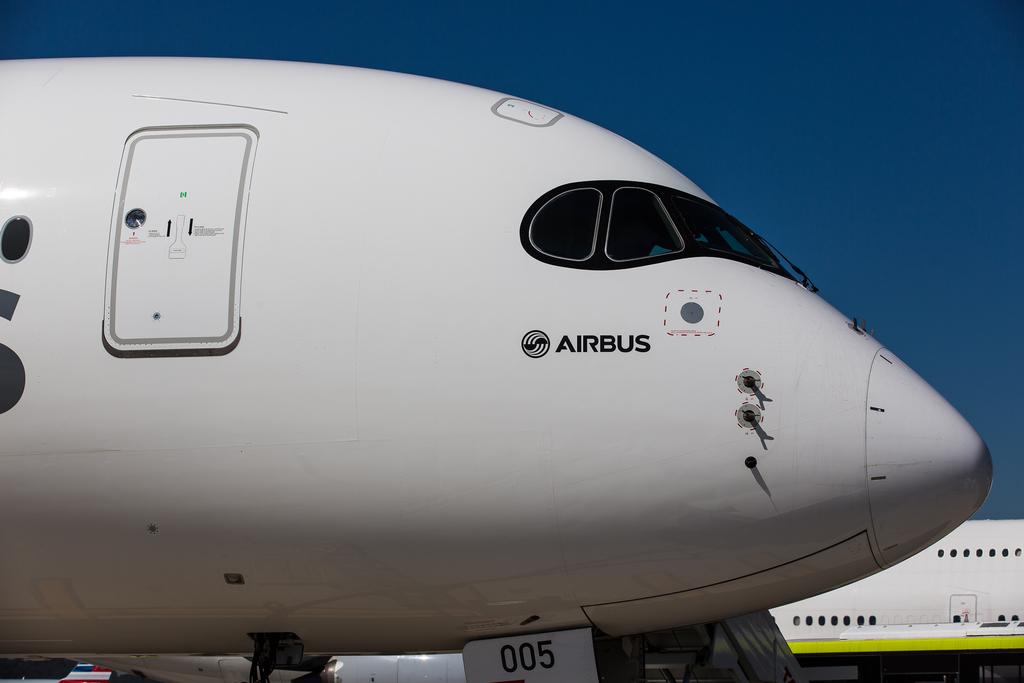What is brand of plane?
Offer a terse response. Airbus. What company logo is pictured?
Ensure brevity in your answer.  Airbus. 